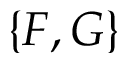<formula> <loc_0><loc_0><loc_500><loc_500>\{ F , G \}</formula> 